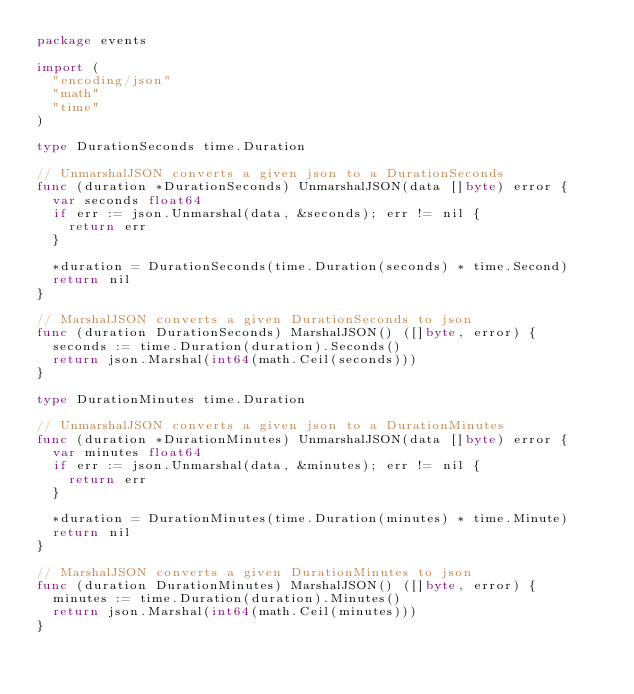Convert code to text. <code><loc_0><loc_0><loc_500><loc_500><_Go_>package events

import (
	"encoding/json"
	"math"
	"time"
)

type DurationSeconds time.Duration

// UnmarshalJSON converts a given json to a DurationSeconds
func (duration *DurationSeconds) UnmarshalJSON(data []byte) error {
	var seconds float64
	if err := json.Unmarshal(data, &seconds); err != nil {
		return err
	}

	*duration = DurationSeconds(time.Duration(seconds) * time.Second)
	return nil
}

// MarshalJSON converts a given DurationSeconds to json
func (duration DurationSeconds) MarshalJSON() ([]byte, error) {
	seconds := time.Duration(duration).Seconds()
	return json.Marshal(int64(math.Ceil(seconds)))
}

type DurationMinutes time.Duration

// UnmarshalJSON converts a given json to a DurationMinutes
func (duration *DurationMinutes) UnmarshalJSON(data []byte) error {
	var minutes float64
	if err := json.Unmarshal(data, &minutes); err != nil {
		return err
	}

	*duration = DurationMinutes(time.Duration(minutes) * time.Minute)
	return nil
}

// MarshalJSON converts a given DurationMinutes to json
func (duration DurationMinutes) MarshalJSON() ([]byte, error) {
	minutes := time.Duration(duration).Minutes()
	return json.Marshal(int64(math.Ceil(minutes)))
}
</code> 